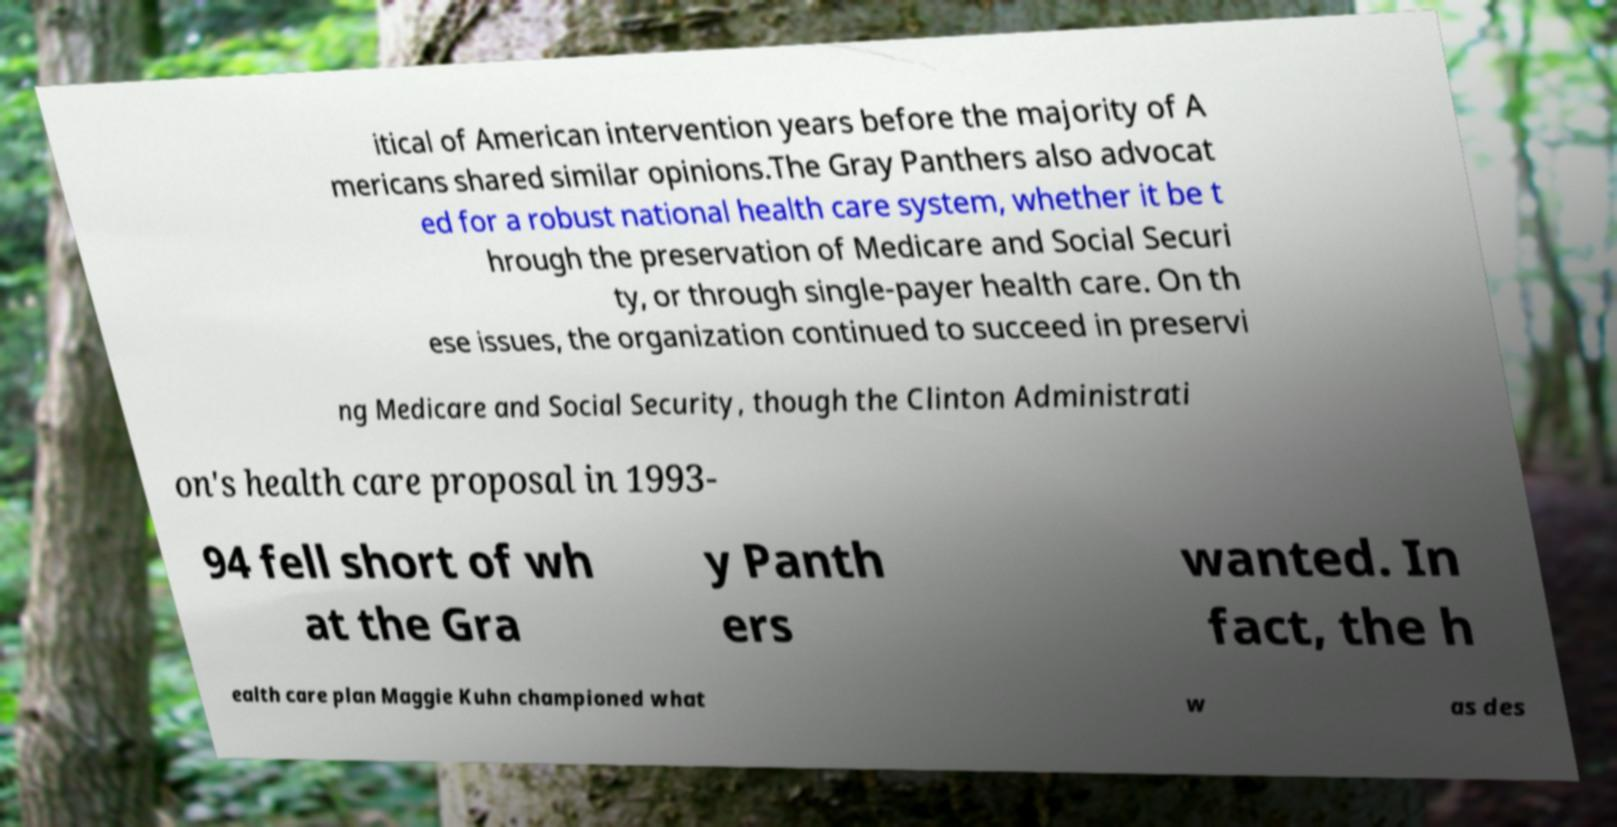For documentation purposes, I need the text within this image transcribed. Could you provide that? itical of American intervention years before the majority of A mericans shared similar opinions.The Gray Panthers also advocat ed for a robust national health care system, whether it be t hrough the preservation of Medicare and Social Securi ty, or through single-payer health care. On th ese issues, the organization continued to succeed in preservi ng Medicare and Social Security, though the Clinton Administrati on's health care proposal in 1993- 94 fell short of wh at the Gra y Panth ers wanted. In fact, the h ealth care plan Maggie Kuhn championed what w as des 